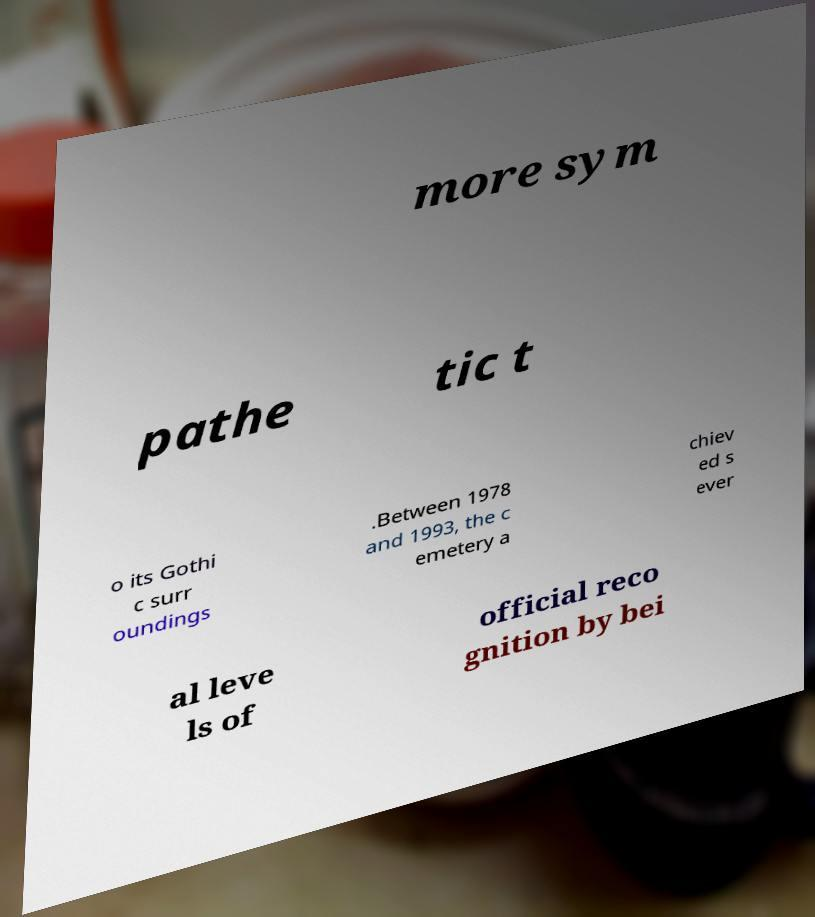Can you read and provide the text displayed in the image?This photo seems to have some interesting text. Can you extract and type it out for me? more sym pathe tic t o its Gothi c surr oundings .Between 1978 and 1993, the c emetery a chiev ed s ever al leve ls of official reco gnition by bei 